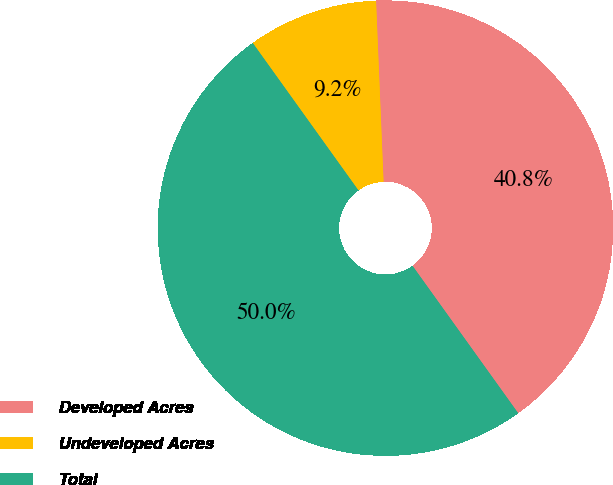<chart> <loc_0><loc_0><loc_500><loc_500><pie_chart><fcel>Developed Acres<fcel>Undeveloped Acres<fcel>Total<nl><fcel>40.76%<fcel>9.24%<fcel>50.0%<nl></chart> 